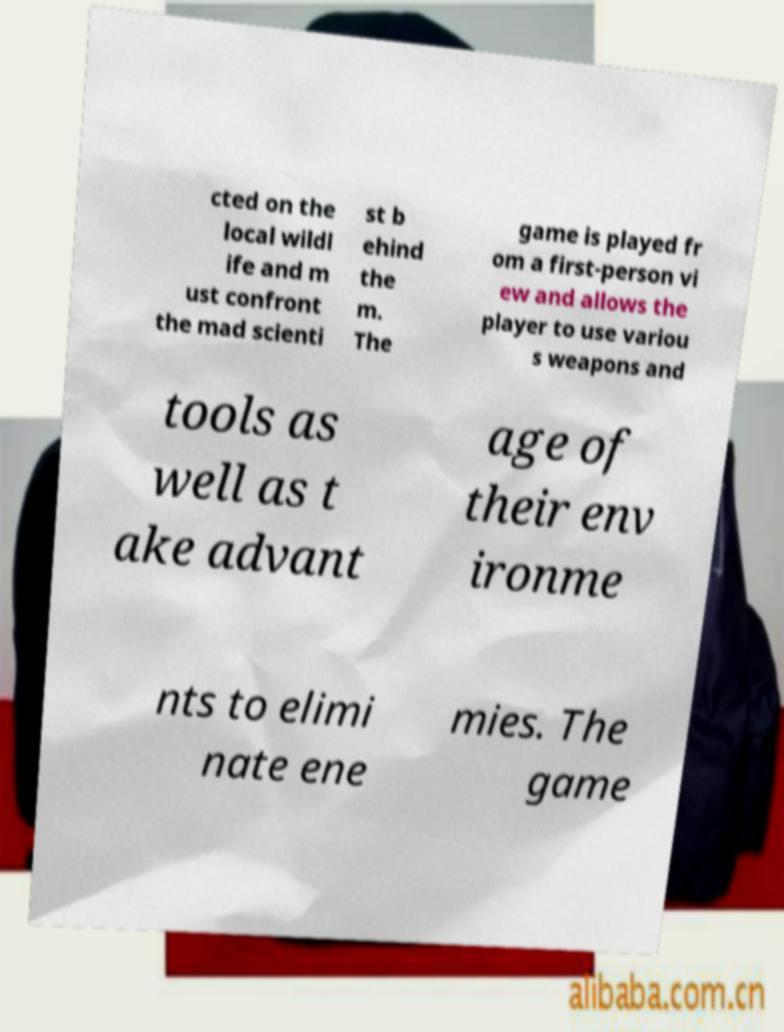Could you extract and type out the text from this image? cted on the local wildl ife and m ust confront the mad scienti st b ehind the m. The game is played fr om a first-person vi ew and allows the player to use variou s weapons and tools as well as t ake advant age of their env ironme nts to elimi nate ene mies. The game 